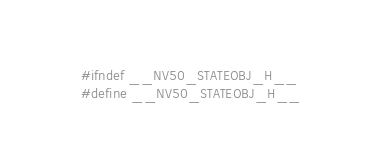<code> <loc_0><loc_0><loc_500><loc_500><_C_>
#ifndef __NV50_STATEOBJ_H__
#define __NV50_STATEOBJ_H__
</code> 